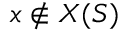Convert formula to latex. <formula><loc_0><loc_0><loc_500><loc_500>x \notin X ( S )</formula> 